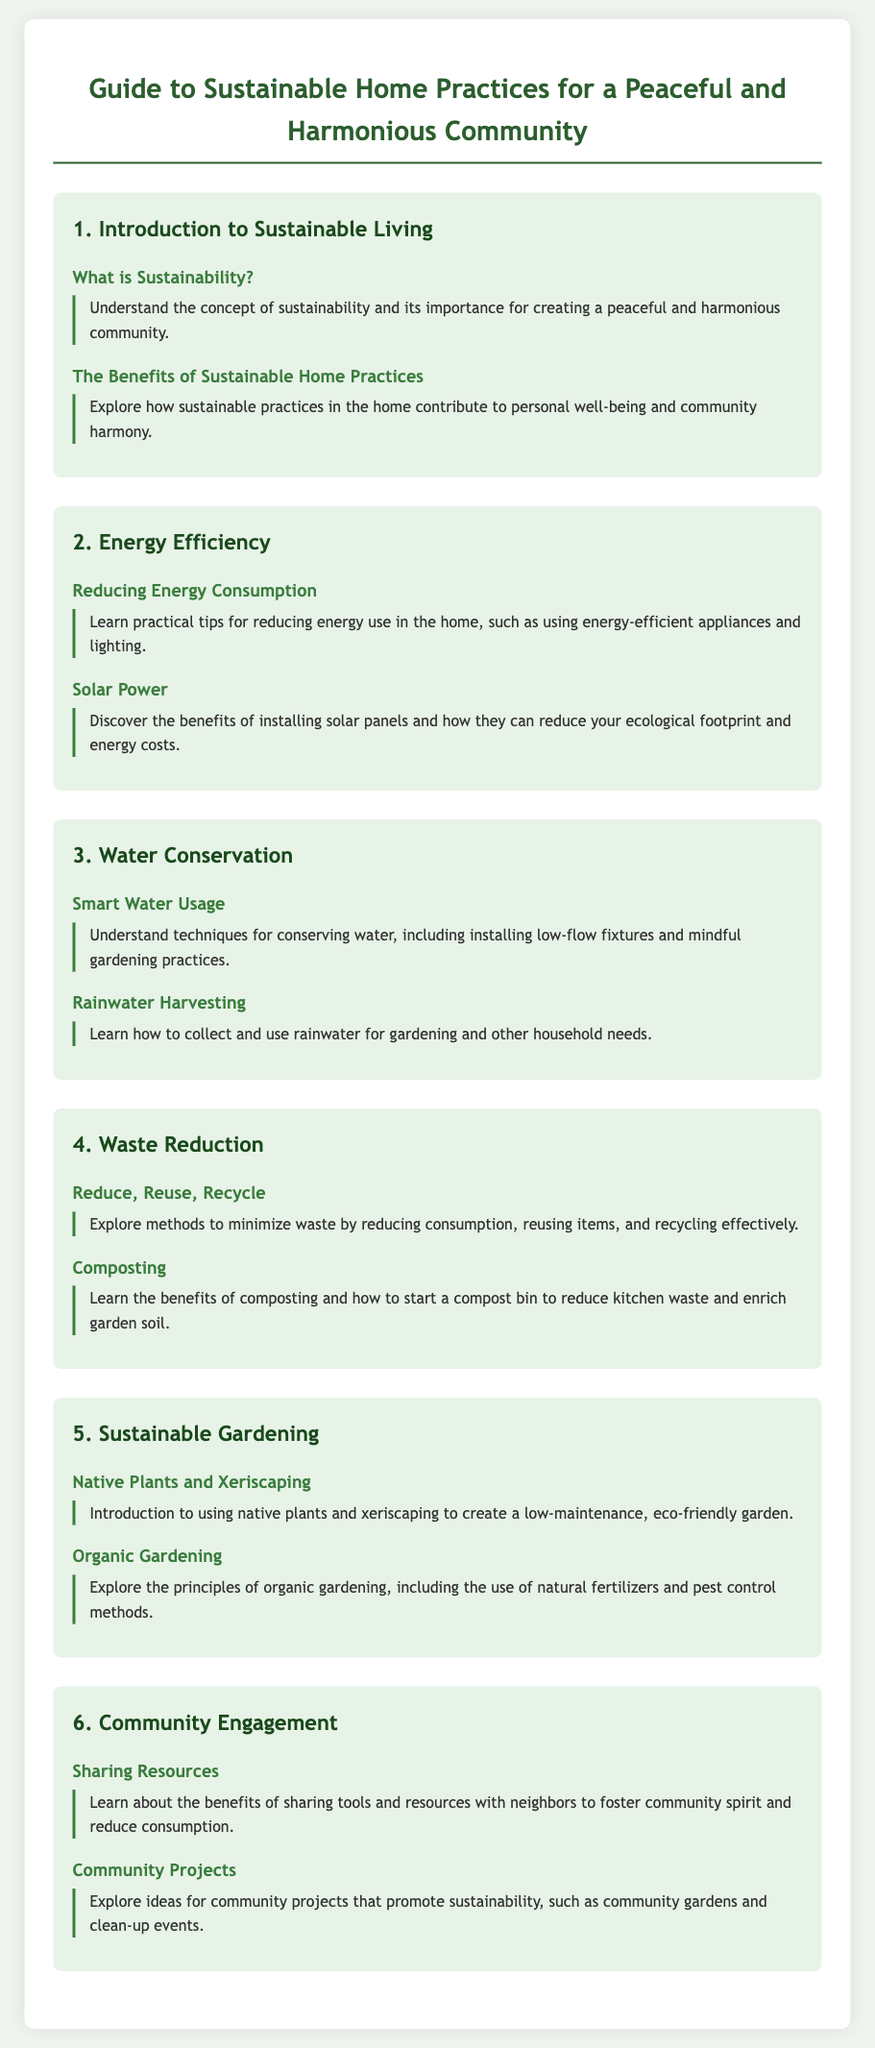What is sustainability? The document answers this in the section titled "What is Sustainability?" in the introduction, defining it as a concept important for community harmony.
Answer: Understand the concept of sustainability What are the benefits of sustainable home practices? This is discussed under "The Benefits of Sustainable Home Practices," highlighting personal well-being and community harmony.
Answer: Personal well-being and community harmony What is one practical tip for reducing energy use? The section "Reducing Energy Consumption" provides practical tips including using energy-efficient appliances.
Answer: Using energy-efficient appliances What does rainwater harvesting involve? This is explained in the section "Rainwater Harvesting," focusing on collecting and using rainwater.
Answer: Collecting and using rainwater What methods are included in waste reduction? The section titled "Reduce, Reuse, Recycle" outlines methods for minimizing waste consumption.
Answer: Reducing consumption, reusing items, recycling What is one of the principles of organic gardening? The section "Organic Gardening" discusses principles including the use of natural fertilizers.
Answer: Use of natural fertilizers How does sharing resources benefit the community? The "Sharing Resources" section mentions fostering community spirit and reducing consumption.
Answer: Foster community spirit and reduce consumption What type of gardening is mentioned for low maintenance? The term "xeriscaping" is introduced in the section "Native Plants and Xeriscaping" for eco-friendly gardening.
Answer: Xeriscaping 